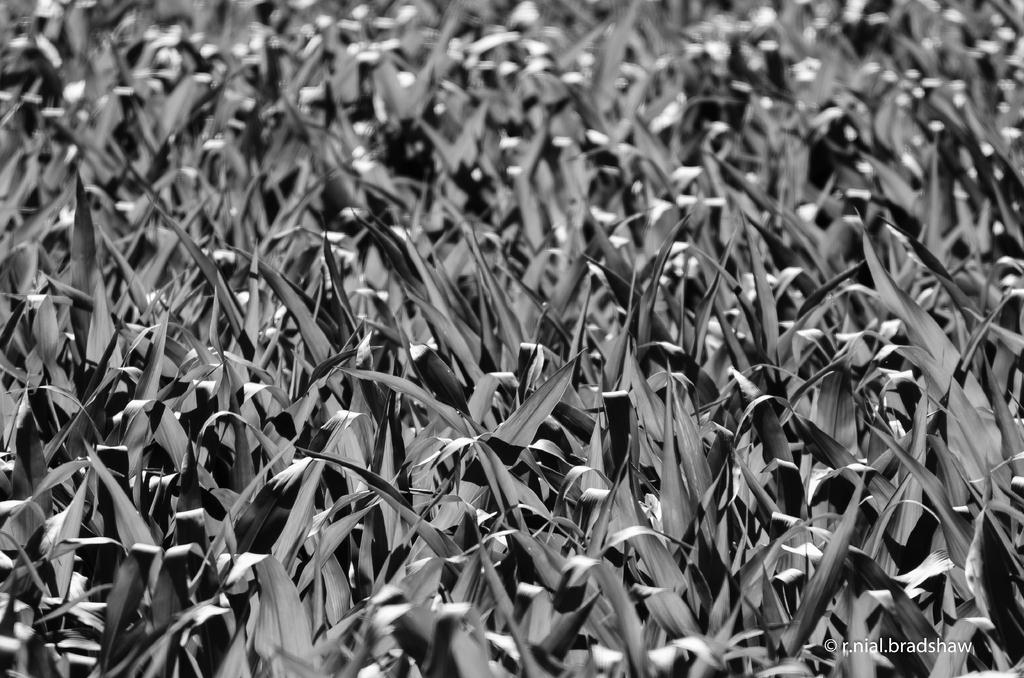What is the color scheme of the image? The image is black and white. What type of natural elements can be seen in the image? There are leaves visible in the image. Is there any text or logo present in the image? Yes, there is a watermark in the image. What type of sofa can be seen in the image? There is no sofa present in the image; it only contains leaves and a watermark. What route is depicted in the image? The image does not show a route; it is a black and white image with leaves and a watermark. 